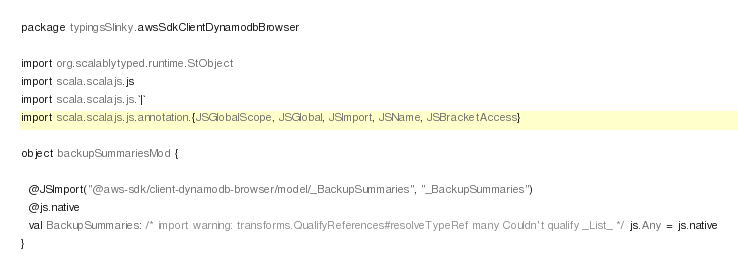<code> <loc_0><loc_0><loc_500><loc_500><_Scala_>package typingsSlinky.awsSdkClientDynamodbBrowser

import org.scalablytyped.runtime.StObject
import scala.scalajs.js
import scala.scalajs.js.`|`
import scala.scalajs.js.annotation.{JSGlobalScope, JSGlobal, JSImport, JSName, JSBracketAccess}

object backupSummariesMod {
  
  @JSImport("@aws-sdk/client-dynamodb-browser/model/_BackupSummaries", "_BackupSummaries")
  @js.native
  val BackupSummaries: /* import warning: transforms.QualifyReferences#resolveTypeRef many Couldn't qualify _List_ */ js.Any = js.native
}
</code> 